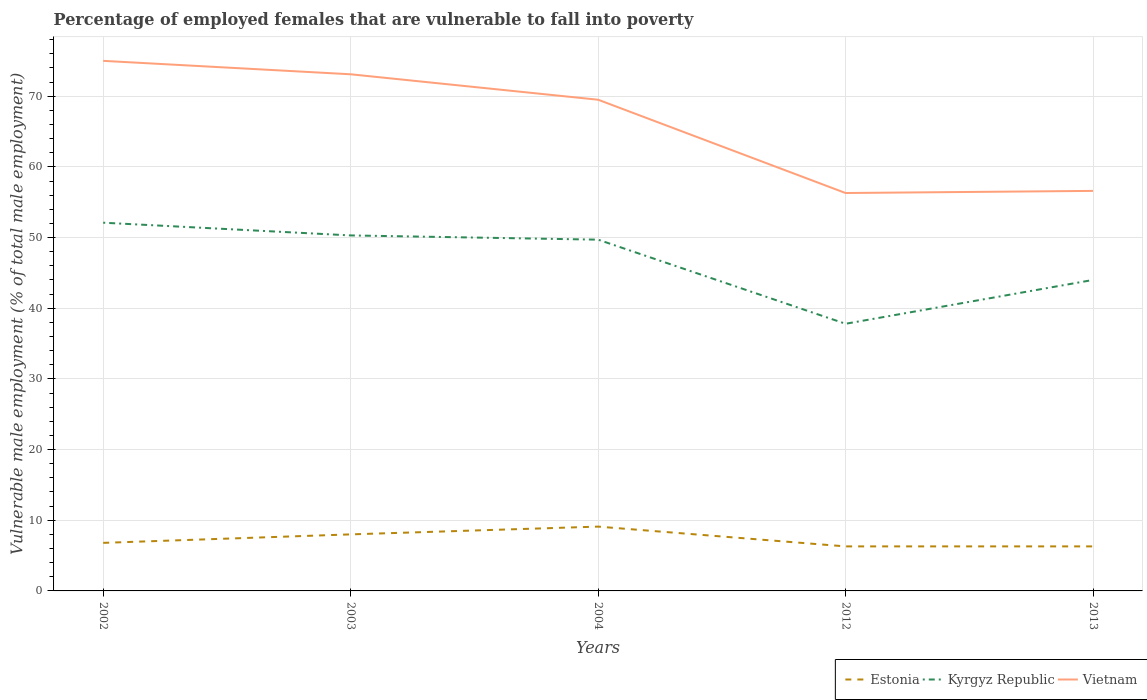How many different coloured lines are there?
Your answer should be compact. 3. Does the line corresponding to Estonia intersect with the line corresponding to Kyrgyz Republic?
Provide a short and direct response. No. Is the number of lines equal to the number of legend labels?
Offer a very short reply. Yes. Across all years, what is the maximum percentage of employed females who are vulnerable to fall into poverty in Kyrgyz Republic?
Keep it short and to the point. 37.8. What is the total percentage of employed females who are vulnerable to fall into poverty in Kyrgyz Republic in the graph?
Your answer should be compact. 6.3. What is the difference between the highest and the second highest percentage of employed females who are vulnerable to fall into poverty in Estonia?
Your answer should be compact. 2.8. What is the difference between two consecutive major ticks on the Y-axis?
Offer a terse response. 10. Does the graph contain any zero values?
Keep it short and to the point. No. How many legend labels are there?
Make the answer very short. 3. What is the title of the graph?
Provide a short and direct response. Percentage of employed females that are vulnerable to fall into poverty. What is the label or title of the Y-axis?
Ensure brevity in your answer.  Vulnerable male employment (% of total male employment). What is the Vulnerable male employment (% of total male employment) in Estonia in 2002?
Give a very brief answer. 6.8. What is the Vulnerable male employment (% of total male employment) of Kyrgyz Republic in 2002?
Make the answer very short. 52.1. What is the Vulnerable male employment (% of total male employment) in Kyrgyz Republic in 2003?
Ensure brevity in your answer.  50.3. What is the Vulnerable male employment (% of total male employment) in Vietnam in 2003?
Provide a short and direct response. 73.1. What is the Vulnerable male employment (% of total male employment) in Estonia in 2004?
Keep it short and to the point. 9.1. What is the Vulnerable male employment (% of total male employment) of Kyrgyz Republic in 2004?
Make the answer very short. 49.7. What is the Vulnerable male employment (% of total male employment) in Vietnam in 2004?
Provide a short and direct response. 69.5. What is the Vulnerable male employment (% of total male employment) of Estonia in 2012?
Make the answer very short. 6.3. What is the Vulnerable male employment (% of total male employment) of Kyrgyz Republic in 2012?
Ensure brevity in your answer.  37.8. What is the Vulnerable male employment (% of total male employment) in Vietnam in 2012?
Your response must be concise. 56.3. What is the Vulnerable male employment (% of total male employment) of Estonia in 2013?
Provide a succinct answer. 6.3. What is the Vulnerable male employment (% of total male employment) of Vietnam in 2013?
Provide a short and direct response. 56.6. Across all years, what is the maximum Vulnerable male employment (% of total male employment) of Estonia?
Your answer should be compact. 9.1. Across all years, what is the maximum Vulnerable male employment (% of total male employment) of Kyrgyz Republic?
Provide a succinct answer. 52.1. Across all years, what is the minimum Vulnerable male employment (% of total male employment) in Estonia?
Your answer should be compact. 6.3. Across all years, what is the minimum Vulnerable male employment (% of total male employment) in Kyrgyz Republic?
Make the answer very short. 37.8. Across all years, what is the minimum Vulnerable male employment (% of total male employment) in Vietnam?
Give a very brief answer. 56.3. What is the total Vulnerable male employment (% of total male employment) in Estonia in the graph?
Make the answer very short. 36.5. What is the total Vulnerable male employment (% of total male employment) of Kyrgyz Republic in the graph?
Provide a short and direct response. 233.9. What is the total Vulnerable male employment (% of total male employment) of Vietnam in the graph?
Your answer should be compact. 330.5. What is the difference between the Vulnerable male employment (% of total male employment) of Estonia in 2002 and that in 2003?
Offer a terse response. -1.2. What is the difference between the Vulnerable male employment (% of total male employment) of Vietnam in 2002 and that in 2003?
Your answer should be compact. 1.9. What is the difference between the Vulnerable male employment (% of total male employment) in Estonia in 2002 and that in 2012?
Give a very brief answer. 0.5. What is the difference between the Vulnerable male employment (% of total male employment) in Kyrgyz Republic in 2002 and that in 2012?
Provide a short and direct response. 14.3. What is the difference between the Vulnerable male employment (% of total male employment) in Vietnam in 2002 and that in 2012?
Offer a very short reply. 18.7. What is the difference between the Vulnerable male employment (% of total male employment) of Estonia in 2002 and that in 2013?
Your answer should be compact. 0.5. What is the difference between the Vulnerable male employment (% of total male employment) of Estonia in 2003 and that in 2004?
Ensure brevity in your answer.  -1.1. What is the difference between the Vulnerable male employment (% of total male employment) in Kyrgyz Republic in 2003 and that in 2004?
Your response must be concise. 0.6. What is the difference between the Vulnerable male employment (% of total male employment) of Vietnam in 2003 and that in 2012?
Offer a very short reply. 16.8. What is the difference between the Vulnerable male employment (% of total male employment) in Estonia in 2003 and that in 2013?
Your answer should be very brief. 1.7. What is the difference between the Vulnerable male employment (% of total male employment) of Kyrgyz Republic in 2003 and that in 2013?
Provide a short and direct response. 6.3. What is the difference between the Vulnerable male employment (% of total male employment) in Vietnam in 2003 and that in 2013?
Make the answer very short. 16.5. What is the difference between the Vulnerable male employment (% of total male employment) of Vietnam in 2004 and that in 2012?
Your answer should be compact. 13.2. What is the difference between the Vulnerable male employment (% of total male employment) of Kyrgyz Republic in 2012 and that in 2013?
Offer a very short reply. -6.2. What is the difference between the Vulnerable male employment (% of total male employment) of Vietnam in 2012 and that in 2013?
Give a very brief answer. -0.3. What is the difference between the Vulnerable male employment (% of total male employment) of Estonia in 2002 and the Vulnerable male employment (% of total male employment) of Kyrgyz Republic in 2003?
Your answer should be very brief. -43.5. What is the difference between the Vulnerable male employment (% of total male employment) of Estonia in 2002 and the Vulnerable male employment (% of total male employment) of Vietnam in 2003?
Provide a succinct answer. -66.3. What is the difference between the Vulnerable male employment (% of total male employment) in Kyrgyz Republic in 2002 and the Vulnerable male employment (% of total male employment) in Vietnam in 2003?
Offer a terse response. -21. What is the difference between the Vulnerable male employment (% of total male employment) of Estonia in 2002 and the Vulnerable male employment (% of total male employment) of Kyrgyz Republic in 2004?
Your answer should be very brief. -42.9. What is the difference between the Vulnerable male employment (% of total male employment) in Estonia in 2002 and the Vulnerable male employment (% of total male employment) in Vietnam in 2004?
Ensure brevity in your answer.  -62.7. What is the difference between the Vulnerable male employment (% of total male employment) in Kyrgyz Republic in 2002 and the Vulnerable male employment (% of total male employment) in Vietnam in 2004?
Keep it short and to the point. -17.4. What is the difference between the Vulnerable male employment (% of total male employment) of Estonia in 2002 and the Vulnerable male employment (% of total male employment) of Kyrgyz Republic in 2012?
Provide a succinct answer. -31. What is the difference between the Vulnerable male employment (% of total male employment) of Estonia in 2002 and the Vulnerable male employment (% of total male employment) of Vietnam in 2012?
Keep it short and to the point. -49.5. What is the difference between the Vulnerable male employment (% of total male employment) in Estonia in 2002 and the Vulnerable male employment (% of total male employment) in Kyrgyz Republic in 2013?
Give a very brief answer. -37.2. What is the difference between the Vulnerable male employment (% of total male employment) in Estonia in 2002 and the Vulnerable male employment (% of total male employment) in Vietnam in 2013?
Ensure brevity in your answer.  -49.8. What is the difference between the Vulnerable male employment (% of total male employment) in Kyrgyz Republic in 2002 and the Vulnerable male employment (% of total male employment) in Vietnam in 2013?
Ensure brevity in your answer.  -4.5. What is the difference between the Vulnerable male employment (% of total male employment) of Estonia in 2003 and the Vulnerable male employment (% of total male employment) of Kyrgyz Republic in 2004?
Your answer should be very brief. -41.7. What is the difference between the Vulnerable male employment (% of total male employment) of Estonia in 2003 and the Vulnerable male employment (% of total male employment) of Vietnam in 2004?
Give a very brief answer. -61.5. What is the difference between the Vulnerable male employment (% of total male employment) in Kyrgyz Republic in 2003 and the Vulnerable male employment (% of total male employment) in Vietnam in 2004?
Give a very brief answer. -19.2. What is the difference between the Vulnerable male employment (% of total male employment) of Estonia in 2003 and the Vulnerable male employment (% of total male employment) of Kyrgyz Republic in 2012?
Make the answer very short. -29.8. What is the difference between the Vulnerable male employment (% of total male employment) of Estonia in 2003 and the Vulnerable male employment (% of total male employment) of Vietnam in 2012?
Offer a terse response. -48.3. What is the difference between the Vulnerable male employment (% of total male employment) in Estonia in 2003 and the Vulnerable male employment (% of total male employment) in Kyrgyz Republic in 2013?
Provide a succinct answer. -36. What is the difference between the Vulnerable male employment (% of total male employment) of Estonia in 2003 and the Vulnerable male employment (% of total male employment) of Vietnam in 2013?
Your answer should be compact. -48.6. What is the difference between the Vulnerable male employment (% of total male employment) of Kyrgyz Republic in 2003 and the Vulnerable male employment (% of total male employment) of Vietnam in 2013?
Make the answer very short. -6.3. What is the difference between the Vulnerable male employment (% of total male employment) of Estonia in 2004 and the Vulnerable male employment (% of total male employment) of Kyrgyz Republic in 2012?
Offer a very short reply. -28.7. What is the difference between the Vulnerable male employment (% of total male employment) of Estonia in 2004 and the Vulnerable male employment (% of total male employment) of Vietnam in 2012?
Your response must be concise. -47.2. What is the difference between the Vulnerable male employment (% of total male employment) of Kyrgyz Republic in 2004 and the Vulnerable male employment (% of total male employment) of Vietnam in 2012?
Offer a very short reply. -6.6. What is the difference between the Vulnerable male employment (% of total male employment) in Estonia in 2004 and the Vulnerable male employment (% of total male employment) in Kyrgyz Republic in 2013?
Offer a very short reply. -34.9. What is the difference between the Vulnerable male employment (% of total male employment) in Estonia in 2004 and the Vulnerable male employment (% of total male employment) in Vietnam in 2013?
Your response must be concise. -47.5. What is the difference between the Vulnerable male employment (% of total male employment) of Estonia in 2012 and the Vulnerable male employment (% of total male employment) of Kyrgyz Republic in 2013?
Offer a very short reply. -37.7. What is the difference between the Vulnerable male employment (% of total male employment) in Estonia in 2012 and the Vulnerable male employment (% of total male employment) in Vietnam in 2013?
Offer a very short reply. -50.3. What is the difference between the Vulnerable male employment (% of total male employment) in Kyrgyz Republic in 2012 and the Vulnerable male employment (% of total male employment) in Vietnam in 2013?
Your response must be concise. -18.8. What is the average Vulnerable male employment (% of total male employment) in Estonia per year?
Offer a terse response. 7.3. What is the average Vulnerable male employment (% of total male employment) of Kyrgyz Republic per year?
Your answer should be compact. 46.78. What is the average Vulnerable male employment (% of total male employment) of Vietnam per year?
Keep it short and to the point. 66.1. In the year 2002, what is the difference between the Vulnerable male employment (% of total male employment) in Estonia and Vulnerable male employment (% of total male employment) in Kyrgyz Republic?
Keep it short and to the point. -45.3. In the year 2002, what is the difference between the Vulnerable male employment (% of total male employment) in Estonia and Vulnerable male employment (% of total male employment) in Vietnam?
Keep it short and to the point. -68.2. In the year 2002, what is the difference between the Vulnerable male employment (% of total male employment) of Kyrgyz Republic and Vulnerable male employment (% of total male employment) of Vietnam?
Your answer should be compact. -22.9. In the year 2003, what is the difference between the Vulnerable male employment (% of total male employment) in Estonia and Vulnerable male employment (% of total male employment) in Kyrgyz Republic?
Provide a short and direct response. -42.3. In the year 2003, what is the difference between the Vulnerable male employment (% of total male employment) in Estonia and Vulnerable male employment (% of total male employment) in Vietnam?
Your response must be concise. -65.1. In the year 2003, what is the difference between the Vulnerable male employment (% of total male employment) in Kyrgyz Republic and Vulnerable male employment (% of total male employment) in Vietnam?
Make the answer very short. -22.8. In the year 2004, what is the difference between the Vulnerable male employment (% of total male employment) of Estonia and Vulnerable male employment (% of total male employment) of Kyrgyz Republic?
Offer a very short reply. -40.6. In the year 2004, what is the difference between the Vulnerable male employment (% of total male employment) of Estonia and Vulnerable male employment (% of total male employment) of Vietnam?
Your answer should be compact. -60.4. In the year 2004, what is the difference between the Vulnerable male employment (% of total male employment) in Kyrgyz Republic and Vulnerable male employment (% of total male employment) in Vietnam?
Ensure brevity in your answer.  -19.8. In the year 2012, what is the difference between the Vulnerable male employment (% of total male employment) in Estonia and Vulnerable male employment (% of total male employment) in Kyrgyz Republic?
Your response must be concise. -31.5. In the year 2012, what is the difference between the Vulnerable male employment (% of total male employment) of Estonia and Vulnerable male employment (% of total male employment) of Vietnam?
Make the answer very short. -50. In the year 2012, what is the difference between the Vulnerable male employment (% of total male employment) of Kyrgyz Republic and Vulnerable male employment (% of total male employment) of Vietnam?
Provide a short and direct response. -18.5. In the year 2013, what is the difference between the Vulnerable male employment (% of total male employment) of Estonia and Vulnerable male employment (% of total male employment) of Kyrgyz Republic?
Your answer should be very brief. -37.7. In the year 2013, what is the difference between the Vulnerable male employment (% of total male employment) of Estonia and Vulnerable male employment (% of total male employment) of Vietnam?
Your answer should be compact. -50.3. What is the ratio of the Vulnerable male employment (% of total male employment) in Estonia in 2002 to that in 2003?
Your answer should be compact. 0.85. What is the ratio of the Vulnerable male employment (% of total male employment) in Kyrgyz Republic in 2002 to that in 2003?
Keep it short and to the point. 1.04. What is the ratio of the Vulnerable male employment (% of total male employment) of Estonia in 2002 to that in 2004?
Ensure brevity in your answer.  0.75. What is the ratio of the Vulnerable male employment (% of total male employment) in Kyrgyz Republic in 2002 to that in 2004?
Give a very brief answer. 1.05. What is the ratio of the Vulnerable male employment (% of total male employment) in Vietnam in 2002 to that in 2004?
Your response must be concise. 1.08. What is the ratio of the Vulnerable male employment (% of total male employment) of Estonia in 2002 to that in 2012?
Provide a succinct answer. 1.08. What is the ratio of the Vulnerable male employment (% of total male employment) of Kyrgyz Republic in 2002 to that in 2012?
Offer a very short reply. 1.38. What is the ratio of the Vulnerable male employment (% of total male employment) in Vietnam in 2002 to that in 2012?
Ensure brevity in your answer.  1.33. What is the ratio of the Vulnerable male employment (% of total male employment) of Estonia in 2002 to that in 2013?
Make the answer very short. 1.08. What is the ratio of the Vulnerable male employment (% of total male employment) of Kyrgyz Republic in 2002 to that in 2013?
Offer a very short reply. 1.18. What is the ratio of the Vulnerable male employment (% of total male employment) of Vietnam in 2002 to that in 2013?
Your answer should be compact. 1.33. What is the ratio of the Vulnerable male employment (% of total male employment) in Estonia in 2003 to that in 2004?
Your response must be concise. 0.88. What is the ratio of the Vulnerable male employment (% of total male employment) in Kyrgyz Republic in 2003 to that in 2004?
Your answer should be compact. 1.01. What is the ratio of the Vulnerable male employment (% of total male employment) in Vietnam in 2003 to that in 2004?
Provide a short and direct response. 1.05. What is the ratio of the Vulnerable male employment (% of total male employment) in Estonia in 2003 to that in 2012?
Give a very brief answer. 1.27. What is the ratio of the Vulnerable male employment (% of total male employment) of Kyrgyz Republic in 2003 to that in 2012?
Offer a terse response. 1.33. What is the ratio of the Vulnerable male employment (% of total male employment) in Vietnam in 2003 to that in 2012?
Provide a succinct answer. 1.3. What is the ratio of the Vulnerable male employment (% of total male employment) of Estonia in 2003 to that in 2013?
Ensure brevity in your answer.  1.27. What is the ratio of the Vulnerable male employment (% of total male employment) in Kyrgyz Republic in 2003 to that in 2013?
Your answer should be compact. 1.14. What is the ratio of the Vulnerable male employment (% of total male employment) of Vietnam in 2003 to that in 2013?
Offer a terse response. 1.29. What is the ratio of the Vulnerable male employment (% of total male employment) in Estonia in 2004 to that in 2012?
Your answer should be very brief. 1.44. What is the ratio of the Vulnerable male employment (% of total male employment) of Kyrgyz Republic in 2004 to that in 2012?
Provide a succinct answer. 1.31. What is the ratio of the Vulnerable male employment (% of total male employment) of Vietnam in 2004 to that in 2012?
Your answer should be compact. 1.23. What is the ratio of the Vulnerable male employment (% of total male employment) in Estonia in 2004 to that in 2013?
Your response must be concise. 1.44. What is the ratio of the Vulnerable male employment (% of total male employment) in Kyrgyz Republic in 2004 to that in 2013?
Give a very brief answer. 1.13. What is the ratio of the Vulnerable male employment (% of total male employment) in Vietnam in 2004 to that in 2013?
Provide a short and direct response. 1.23. What is the ratio of the Vulnerable male employment (% of total male employment) of Estonia in 2012 to that in 2013?
Offer a very short reply. 1. What is the ratio of the Vulnerable male employment (% of total male employment) of Kyrgyz Republic in 2012 to that in 2013?
Ensure brevity in your answer.  0.86. What is the ratio of the Vulnerable male employment (% of total male employment) of Vietnam in 2012 to that in 2013?
Make the answer very short. 0.99. What is the difference between the highest and the second highest Vulnerable male employment (% of total male employment) of Kyrgyz Republic?
Your response must be concise. 1.8. What is the difference between the highest and the lowest Vulnerable male employment (% of total male employment) of Kyrgyz Republic?
Offer a very short reply. 14.3. What is the difference between the highest and the lowest Vulnerable male employment (% of total male employment) in Vietnam?
Your answer should be very brief. 18.7. 